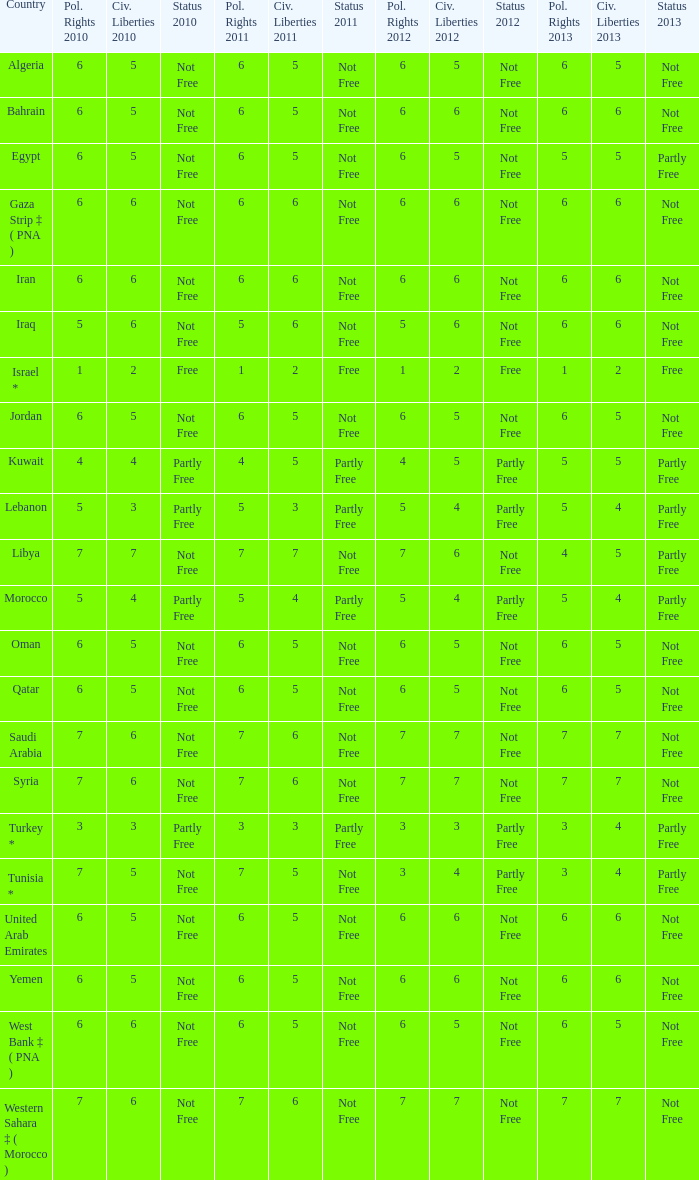What is the average 2012 civil liberties value associated with a 2011 status of not free, political rights 2012 over 6, and political rights 2011 over 7? None. 